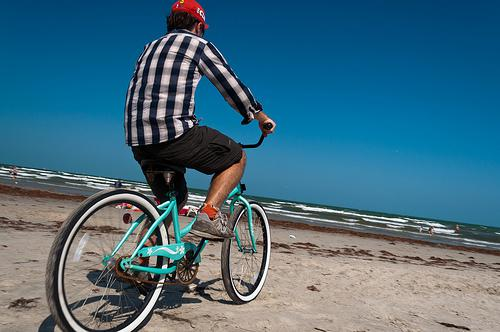Question: how many men are there?
Choices:
A. Two.
B. Three.
C. Four.
D. One.
Answer with the letter. Answer: D Question: what season was this photo taken?
Choices:
A. Summer.
B. Autumn.
C. Spring.
D. Winter.
Answer with the letter. Answer: C Question: who took this photo?
Choices:
A. A police officer.
B. A professional photographer.
C. A sports journalist.
D. A tourist.
Answer with the letter. Answer: D 